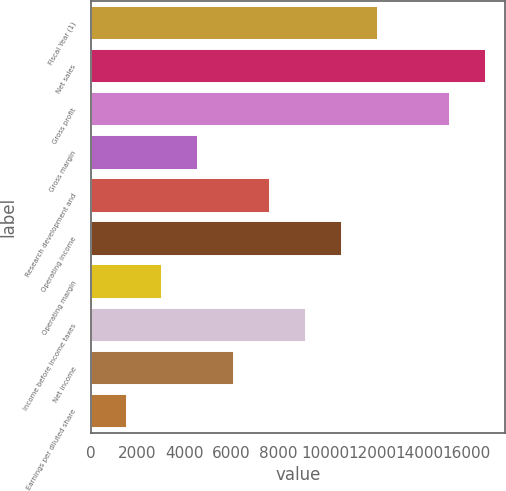<chart> <loc_0><loc_0><loc_500><loc_500><bar_chart><fcel>Fiscal Year (1)<fcel>Net sales<fcel>Gross profit<fcel>Gross margin<fcel>Research development and<fcel>Operating income<fcel>Operating margin<fcel>Income before income taxes<fcel>Net income<fcel>Earnings per diluted share<nl><fcel>12246.5<fcel>16838.8<fcel>15308<fcel>4592.68<fcel>7654.2<fcel>10715.7<fcel>3061.92<fcel>9184.96<fcel>6123.44<fcel>1531.16<nl></chart> 